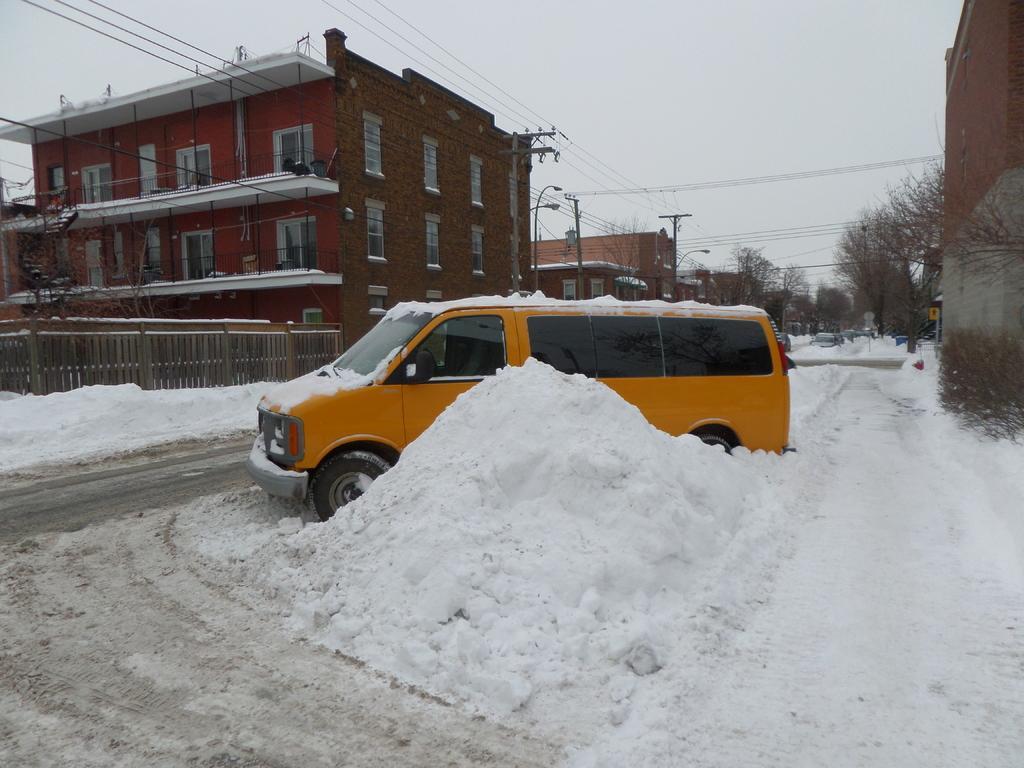In one or two sentences, can you explain what this image depicts? The picture is taken outside a city. In the foreground of the picture there is a vehicle and there is snow, on the road. In the center of the picture there are buildings, trees, street lights, current poles and cables. In the background there are vehicles. Sky is cloudy. 